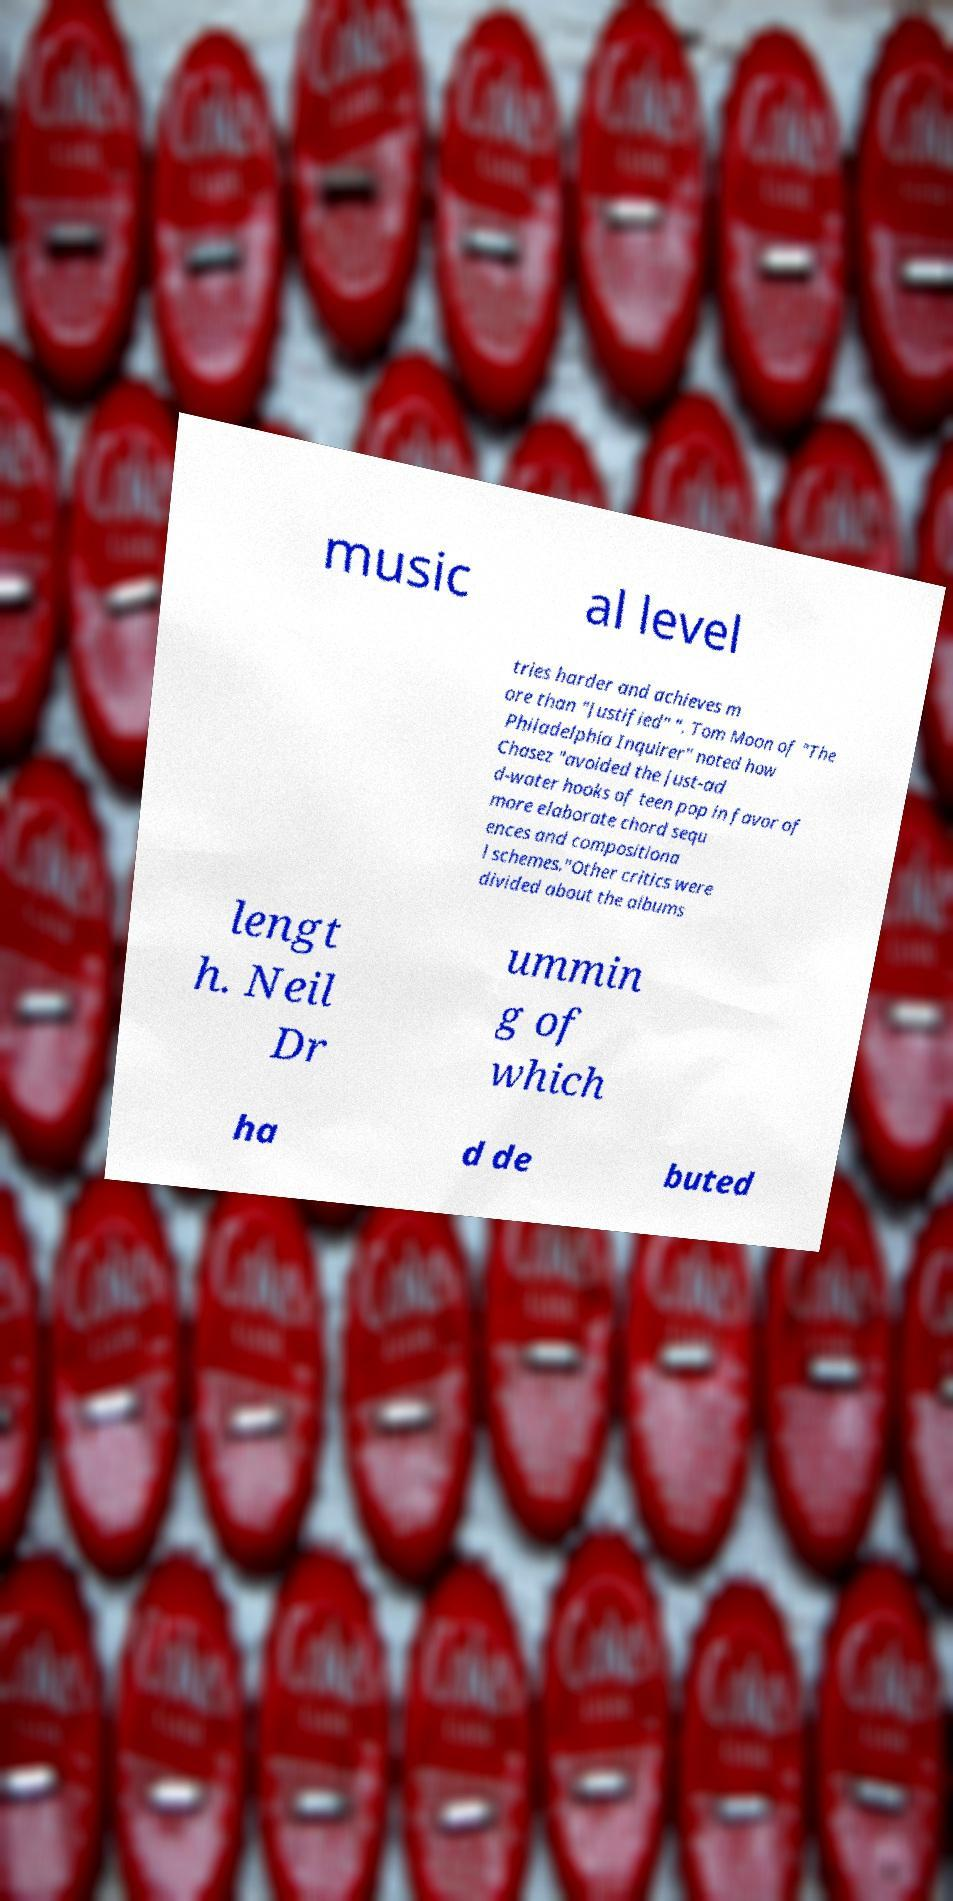I need the written content from this picture converted into text. Can you do that? music al level tries harder and achieves m ore than "Justified" ". Tom Moon of "The Philadelphia Inquirer" noted how Chasez "avoided the just-ad d-water hooks of teen pop in favor of more elaborate chord sequ ences and compositiona l schemes."Other critics were divided about the albums lengt h. Neil Dr ummin g of which ha d de buted 